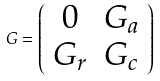Convert formula to latex. <formula><loc_0><loc_0><loc_500><loc_500>G = \left ( \begin{array} { c c } 0 & G _ { a } \\ G _ { r } & G _ { c } \end{array} \right )</formula> 